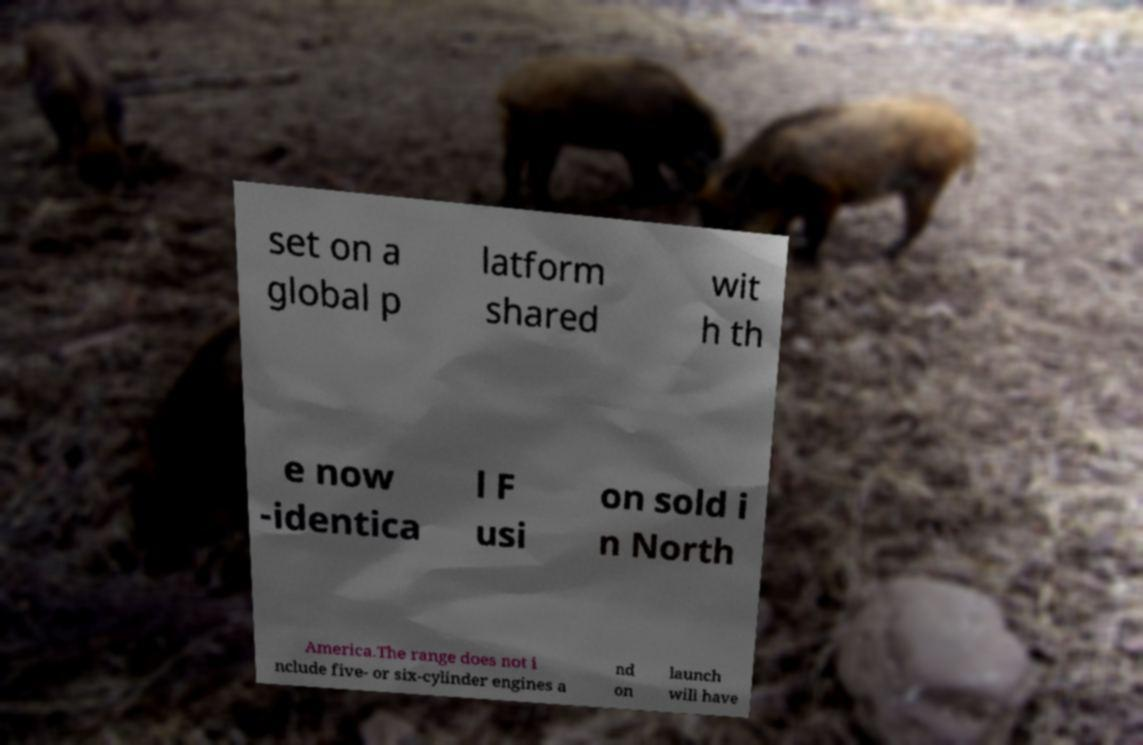Could you assist in decoding the text presented in this image and type it out clearly? set on a global p latform shared wit h th e now -identica l F usi on sold i n North America.The range does not i nclude five- or six-cylinder engines a nd on launch will have 